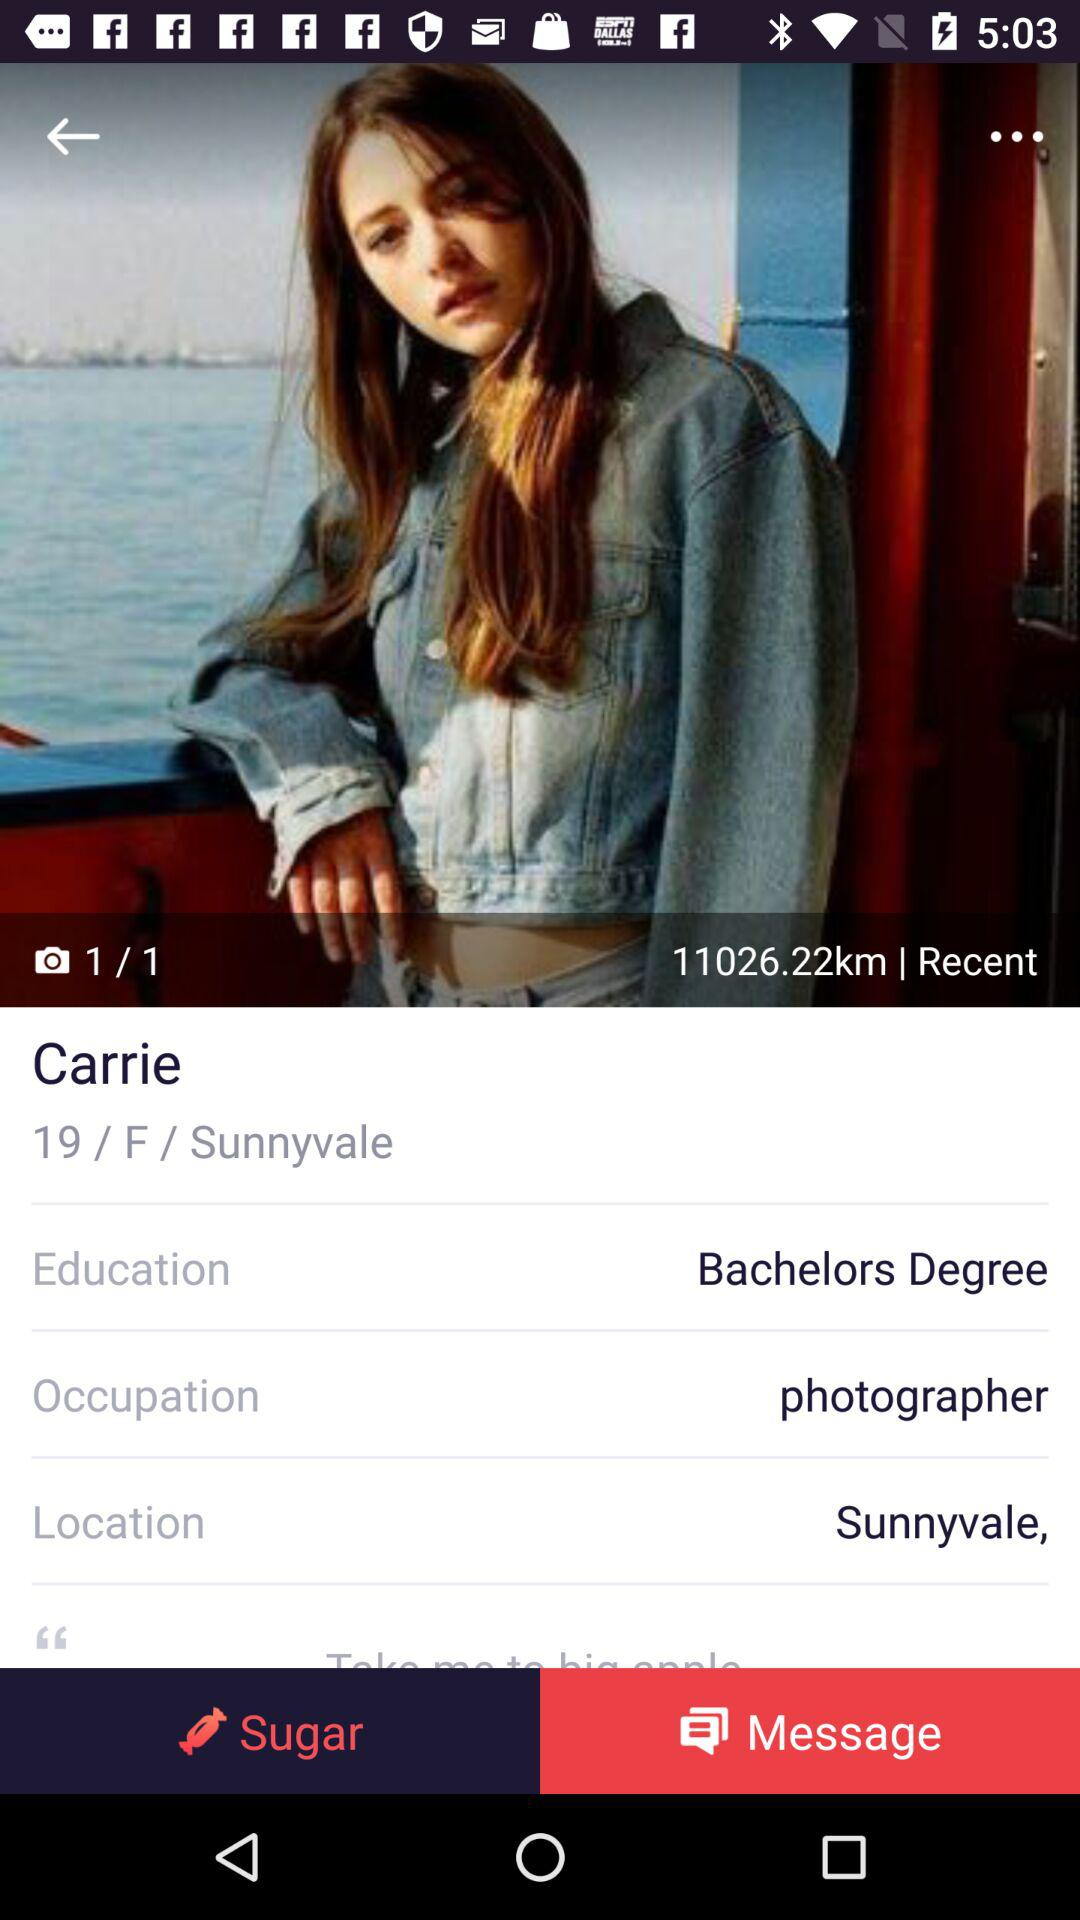What is the education of the girl? The education is bachelor's degree. 